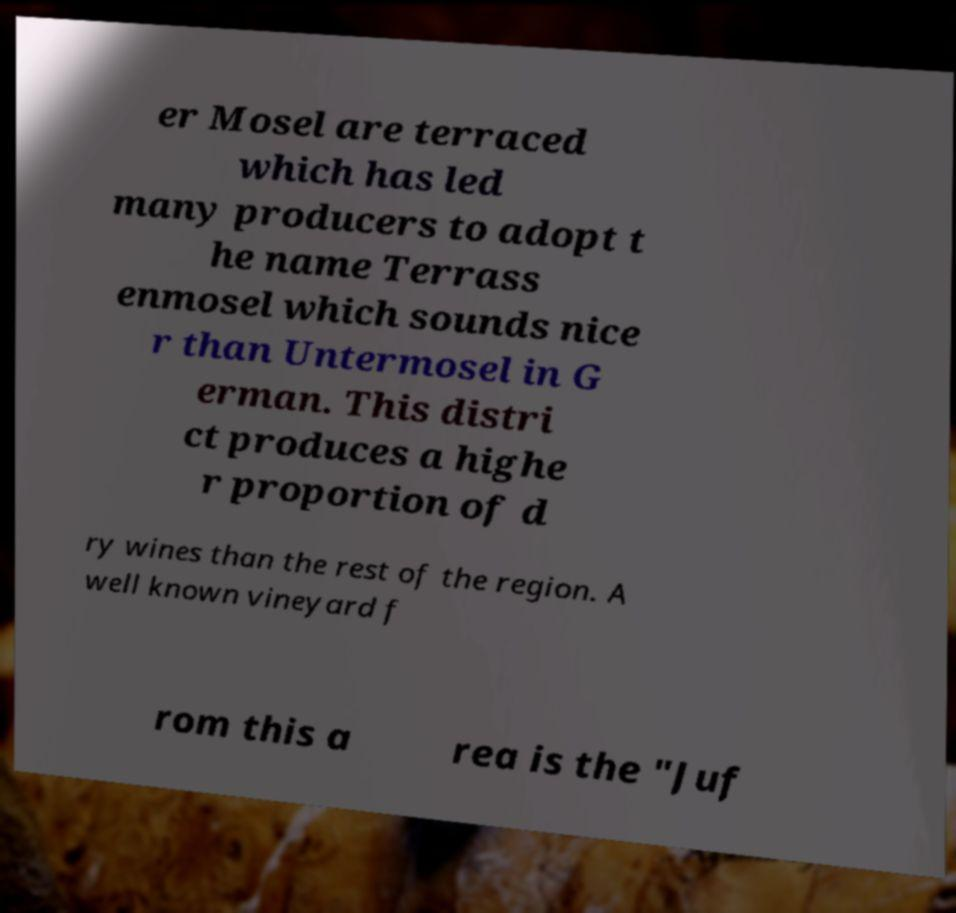Please identify and transcribe the text found in this image. er Mosel are terraced which has led many producers to adopt t he name Terrass enmosel which sounds nice r than Untermosel in G erman. This distri ct produces a highe r proportion of d ry wines than the rest of the region. A well known vineyard f rom this a rea is the "Juf 